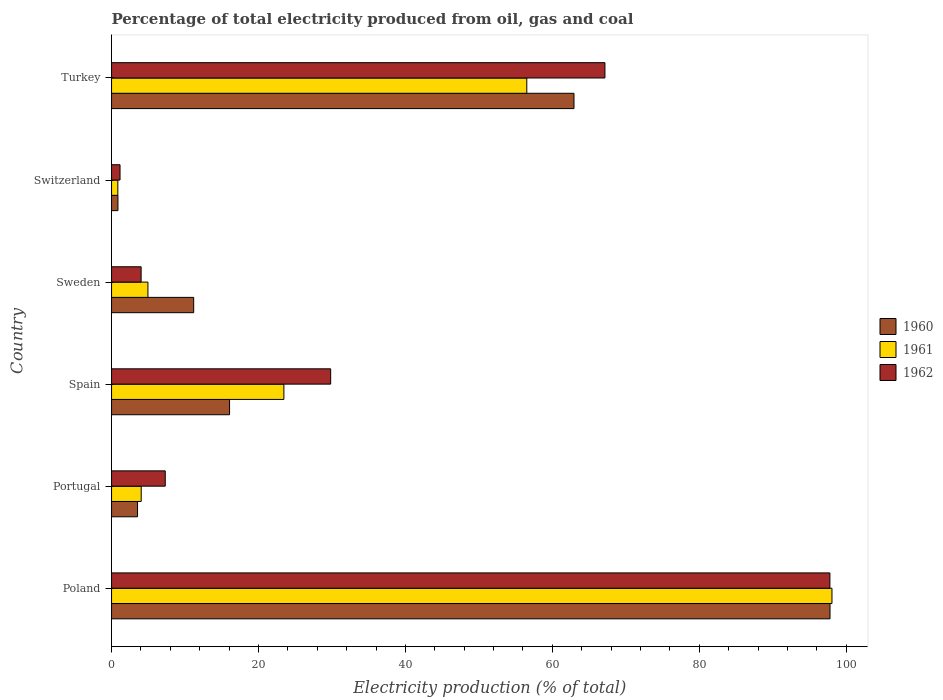How many groups of bars are there?
Provide a short and direct response. 6. Are the number of bars per tick equal to the number of legend labels?
Offer a very short reply. Yes. What is the electricity production in in 1960 in Portugal?
Your response must be concise. 3.54. Across all countries, what is the maximum electricity production in in 1960?
Give a very brief answer. 97.8. Across all countries, what is the minimum electricity production in in 1962?
Make the answer very short. 1.15. In which country was the electricity production in in 1960 maximum?
Ensure brevity in your answer.  Poland. In which country was the electricity production in in 1960 minimum?
Offer a very short reply. Switzerland. What is the total electricity production in in 1961 in the graph?
Provide a short and direct response. 187.9. What is the difference between the electricity production in in 1961 in Poland and that in Turkey?
Your answer should be very brief. 41.54. What is the difference between the electricity production in in 1961 in Switzerland and the electricity production in in 1960 in Sweden?
Offer a terse response. -10.33. What is the average electricity production in in 1961 per country?
Your answer should be compact. 31.32. What is the difference between the electricity production in in 1960 and electricity production in in 1962 in Spain?
Your answer should be very brief. -13.76. What is the ratio of the electricity production in in 1962 in Portugal to that in Turkey?
Offer a very short reply. 0.11. Is the electricity production in in 1960 in Poland less than that in Spain?
Give a very brief answer. No. Is the difference between the electricity production in in 1960 in Sweden and Turkey greater than the difference between the electricity production in in 1962 in Sweden and Turkey?
Give a very brief answer. Yes. What is the difference between the highest and the second highest electricity production in in 1960?
Provide a succinct answer. 34.85. What is the difference between the highest and the lowest electricity production in in 1960?
Make the answer very short. 96.93. What does the 2nd bar from the bottom in Turkey represents?
Your answer should be very brief. 1961. Is it the case that in every country, the sum of the electricity production in in 1960 and electricity production in in 1961 is greater than the electricity production in in 1962?
Keep it short and to the point. Yes. Are all the bars in the graph horizontal?
Your answer should be very brief. Yes. How many countries are there in the graph?
Your answer should be very brief. 6. What is the difference between two consecutive major ticks on the X-axis?
Provide a short and direct response. 20. Are the values on the major ticks of X-axis written in scientific E-notation?
Make the answer very short. No. Does the graph contain any zero values?
Provide a short and direct response. No. Does the graph contain grids?
Provide a short and direct response. No. Where does the legend appear in the graph?
Make the answer very short. Center right. How many legend labels are there?
Give a very brief answer. 3. How are the legend labels stacked?
Ensure brevity in your answer.  Vertical. What is the title of the graph?
Offer a very short reply. Percentage of total electricity produced from oil, gas and coal. What is the label or title of the X-axis?
Give a very brief answer. Electricity production (% of total). What is the Electricity production (% of total) of 1960 in Poland?
Provide a short and direct response. 97.8. What is the Electricity production (% of total) of 1961 in Poland?
Offer a very short reply. 98.07. What is the Electricity production (% of total) of 1962 in Poland?
Offer a very short reply. 97.79. What is the Electricity production (% of total) in 1960 in Portugal?
Provide a short and direct response. 3.54. What is the Electricity production (% of total) of 1961 in Portugal?
Provide a succinct answer. 4.04. What is the Electricity production (% of total) of 1962 in Portugal?
Make the answer very short. 7.31. What is the Electricity production (% of total) in 1960 in Spain?
Give a very brief answer. 16.06. What is the Electricity production (% of total) in 1961 in Spain?
Provide a short and direct response. 23.46. What is the Electricity production (% of total) of 1962 in Spain?
Your response must be concise. 29.83. What is the Electricity production (% of total) of 1960 in Sweden?
Provide a short and direct response. 11.18. What is the Electricity production (% of total) of 1961 in Sweden?
Your answer should be compact. 4.95. What is the Electricity production (% of total) of 1962 in Sweden?
Give a very brief answer. 4.02. What is the Electricity production (% of total) in 1960 in Switzerland?
Your answer should be compact. 0.87. What is the Electricity production (% of total) in 1961 in Switzerland?
Offer a terse response. 0.85. What is the Electricity production (% of total) in 1962 in Switzerland?
Ensure brevity in your answer.  1.15. What is the Electricity production (% of total) of 1960 in Turkey?
Keep it short and to the point. 62.95. What is the Electricity production (% of total) of 1961 in Turkey?
Provide a succinct answer. 56.53. What is the Electricity production (% of total) in 1962 in Turkey?
Provide a short and direct response. 67.16. Across all countries, what is the maximum Electricity production (% of total) in 1960?
Provide a short and direct response. 97.8. Across all countries, what is the maximum Electricity production (% of total) of 1961?
Provide a succinct answer. 98.07. Across all countries, what is the maximum Electricity production (% of total) of 1962?
Offer a very short reply. 97.79. Across all countries, what is the minimum Electricity production (% of total) in 1960?
Keep it short and to the point. 0.87. Across all countries, what is the minimum Electricity production (% of total) in 1961?
Keep it short and to the point. 0.85. Across all countries, what is the minimum Electricity production (% of total) of 1962?
Your answer should be compact. 1.15. What is the total Electricity production (% of total) in 1960 in the graph?
Keep it short and to the point. 192.4. What is the total Electricity production (% of total) of 1961 in the graph?
Give a very brief answer. 187.9. What is the total Electricity production (% of total) in 1962 in the graph?
Provide a short and direct response. 207.26. What is the difference between the Electricity production (% of total) in 1960 in Poland and that in Portugal?
Ensure brevity in your answer.  94.26. What is the difference between the Electricity production (% of total) in 1961 in Poland and that in Portugal?
Offer a very short reply. 94.03. What is the difference between the Electricity production (% of total) in 1962 in Poland and that in Portugal?
Provide a short and direct response. 90.48. What is the difference between the Electricity production (% of total) in 1960 in Poland and that in Spain?
Give a very brief answer. 81.74. What is the difference between the Electricity production (% of total) of 1961 in Poland and that in Spain?
Provide a short and direct response. 74.61. What is the difference between the Electricity production (% of total) in 1962 in Poland and that in Spain?
Make the answer very short. 67.96. What is the difference between the Electricity production (% of total) in 1960 in Poland and that in Sweden?
Give a very brief answer. 86.62. What is the difference between the Electricity production (% of total) in 1961 in Poland and that in Sweden?
Ensure brevity in your answer.  93.12. What is the difference between the Electricity production (% of total) in 1962 in Poland and that in Sweden?
Make the answer very short. 93.76. What is the difference between the Electricity production (% of total) of 1960 in Poland and that in Switzerland?
Provide a succinct answer. 96.93. What is the difference between the Electricity production (% of total) in 1961 in Poland and that in Switzerland?
Provide a short and direct response. 97.21. What is the difference between the Electricity production (% of total) in 1962 in Poland and that in Switzerland?
Keep it short and to the point. 96.63. What is the difference between the Electricity production (% of total) of 1960 in Poland and that in Turkey?
Make the answer very short. 34.85. What is the difference between the Electricity production (% of total) in 1961 in Poland and that in Turkey?
Provide a succinct answer. 41.54. What is the difference between the Electricity production (% of total) of 1962 in Poland and that in Turkey?
Provide a short and direct response. 30.62. What is the difference between the Electricity production (% of total) of 1960 in Portugal and that in Spain?
Offer a very short reply. -12.53. What is the difference between the Electricity production (% of total) of 1961 in Portugal and that in Spain?
Your answer should be compact. -19.42. What is the difference between the Electricity production (% of total) in 1962 in Portugal and that in Spain?
Ensure brevity in your answer.  -22.52. What is the difference between the Electricity production (% of total) of 1960 in Portugal and that in Sweden?
Keep it short and to the point. -7.64. What is the difference between the Electricity production (% of total) of 1961 in Portugal and that in Sweden?
Your response must be concise. -0.92. What is the difference between the Electricity production (% of total) of 1962 in Portugal and that in Sweden?
Offer a terse response. 3.28. What is the difference between the Electricity production (% of total) in 1960 in Portugal and that in Switzerland?
Offer a very short reply. 2.67. What is the difference between the Electricity production (% of total) in 1961 in Portugal and that in Switzerland?
Provide a short and direct response. 3.18. What is the difference between the Electricity production (% of total) of 1962 in Portugal and that in Switzerland?
Make the answer very short. 6.16. What is the difference between the Electricity production (% of total) of 1960 in Portugal and that in Turkey?
Your answer should be very brief. -59.41. What is the difference between the Electricity production (% of total) in 1961 in Portugal and that in Turkey?
Give a very brief answer. -52.49. What is the difference between the Electricity production (% of total) in 1962 in Portugal and that in Turkey?
Your answer should be compact. -59.85. What is the difference between the Electricity production (% of total) in 1960 in Spain and that in Sweden?
Ensure brevity in your answer.  4.88. What is the difference between the Electricity production (% of total) of 1961 in Spain and that in Sweden?
Your answer should be very brief. 18.51. What is the difference between the Electricity production (% of total) of 1962 in Spain and that in Sweden?
Provide a short and direct response. 25.8. What is the difference between the Electricity production (% of total) in 1960 in Spain and that in Switzerland?
Make the answer very short. 15.19. What is the difference between the Electricity production (% of total) in 1961 in Spain and that in Switzerland?
Your response must be concise. 22.61. What is the difference between the Electricity production (% of total) in 1962 in Spain and that in Switzerland?
Give a very brief answer. 28.67. What is the difference between the Electricity production (% of total) of 1960 in Spain and that in Turkey?
Provide a succinct answer. -46.89. What is the difference between the Electricity production (% of total) in 1961 in Spain and that in Turkey?
Provide a short and direct response. -33.07. What is the difference between the Electricity production (% of total) in 1962 in Spain and that in Turkey?
Your response must be concise. -37.34. What is the difference between the Electricity production (% of total) of 1960 in Sweden and that in Switzerland?
Your response must be concise. 10.31. What is the difference between the Electricity production (% of total) of 1961 in Sweden and that in Switzerland?
Your answer should be compact. 4.1. What is the difference between the Electricity production (% of total) of 1962 in Sweden and that in Switzerland?
Your answer should be compact. 2.87. What is the difference between the Electricity production (% of total) of 1960 in Sweden and that in Turkey?
Your answer should be very brief. -51.77. What is the difference between the Electricity production (% of total) in 1961 in Sweden and that in Turkey?
Offer a very short reply. -51.57. What is the difference between the Electricity production (% of total) in 1962 in Sweden and that in Turkey?
Offer a terse response. -63.14. What is the difference between the Electricity production (% of total) of 1960 in Switzerland and that in Turkey?
Provide a short and direct response. -62.08. What is the difference between the Electricity production (% of total) in 1961 in Switzerland and that in Turkey?
Your response must be concise. -55.67. What is the difference between the Electricity production (% of total) in 1962 in Switzerland and that in Turkey?
Offer a very short reply. -66.01. What is the difference between the Electricity production (% of total) of 1960 in Poland and the Electricity production (% of total) of 1961 in Portugal?
Make the answer very short. 93.76. What is the difference between the Electricity production (% of total) of 1960 in Poland and the Electricity production (% of total) of 1962 in Portugal?
Your answer should be compact. 90.49. What is the difference between the Electricity production (% of total) in 1961 in Poland and the Electricity production (% of total) in 1962 in Portugal?
Offer a terse response. 90.76. What is the difference between the Electricity production (% of total) in 1960 in Poland and the Electricity production (% of total) in 1961 in Spain?
Your answer should be compact. 74.34. What is the difference between the Electricity production (% of total) in 1960 in Poland and the Electricity production (% of total) in 1962 in Spain?
Provide a short and direct response. 67.97. What is the difference between the Electricity production (% of total) in 1961 in Poland and the Electricity production (% of total) in 1962 in Spain?
Keep it short and to the point. 68.24. What is the difference between the Electricity production (% of total) in 1960 in Poland and the Electricity production (% of total) in 1961 in Sweden?
Make the answer very short. 92.85. What is the difference between the Electricity production (% of total) of 1960 in Poland and the Electricity production (% of total) of 1962 in Sweden?
Ensure brevity in your answer.  93.78. What is the difference between the Electricity production (% of total) in 1961 in Poland and the Electricity production (% of total) in 1962 in Sweden?
Offer a very short reply. 94.04. What is the difference between the Electricity production (% of total) in 1960 in Poland and the Electricity production (% of total) in 1961 in Switzerland?
Your answer should be very brief. 96.95. What is the difference between the Electricity production (% of total) in 1960 in Poland and the Electricity production (% of total) in 1962 in Switzerland?
Provide a succinct answer. 96.65. What is the difference between the Electricity production (% of total) of 1961 in Poland and the Electricity production (% of total) of 1962 in Switzerland?
Offer a very short reply. 96.91. What is the difference between the Electricity production (% of total) in 1960 in Poland and the Electricity production (% of total) in 1961 in Turkey?
Your response must be concise. 41.27. What is the difference between the Electricity production (% of total) of 1960 in Poland and the Electricity production (% of total) of 1962 in Turkey?
Provide a succinct answer. 30.64. What is the difference between the Electricity production (% of total) of 1961 in Poland and the Electricity production (% of total) of 1962 in Turkey?
Offer a terse response. 30.9. What is the difference between the Electricity production (% of total) of 1960 in Portugal and the Electricity production (% of total) of 1961 in Spain?
Your response must be concise. -19.92. What is the difference between the Electricity production (% of total) of 1960 in Portugal and the Electricity production (% of total) of 1962 in Spain?
Your answer should be compact. -26.29. What is the difference between the Electricity production (% of total) in 1961 in Portugal and the Electricity production (% of total) in 1962 in Spain?
Provide a succinct answer. -25.79. What is the difference between the Electricity production (% of total) of 1960 in Portugal and the Electricity production (% of total) of 1961 in Sweden?
Your answer should be compact. -1.41. What is the difference between the Electricity production (% of total) of 1960 in Portugal and the Electricity production (% of total) of 1962 in Sweden?
Keep it short and to the point. -0.49. What is the difference between the Electricity production (% of total) of 1961 in Portugal and the Electricity production (% of total) of 1962 in Sweden?
Keep it short and to the point. 0.01. What is the difference between the Electricity production (% of total) of 1960 in Portugal and the Electricity production (% of total) of 1961 in Switzerland?
Your answer should be compact. 2.68. What is the difference between the Electricity production (% of total) of 1960 in Portugal and the Electricity production (% of total) of 1962 in Switzerland?
Offer a terse response. 2.38. What is the difference between the Electricity production (% of total) in 1961 in Portugal and the Electricity production (% of total) in 1962 in Switzerland?
Make the answer very short. 2.88. What is the difference between the Electricity production (% of total) in 1960 in Portugal and the Electricity production (% of total) in 1961 in Turkey?
Provide a short and direct response. -52.99. What is the difference between the Electricity production (% of total) of 1960 in Portugal and the Electricity production (% of total) of 1962 in Turkey?
Provide a succinct answer. -63.63. What is the difference between the Electricity production (% of total) of 1961 in Portugal and the Electricity production (% of total) of 1962 in Turkey?
Provide a succinct answer. -63.13. What is the difference between the Electricity production (% of total) in 1960 in Spain and the Electricity production (% of total) in 1961 in Sweden?
Make the answer very short. 11.11. What is the difference between the Electricity production (% of total) of 1960 in Spain and the Electricity production (% of total) of 1962 in Sweden?
Ensure brevity in your answer.  12.04. What is the difference between the Electricity production (% of total) in 1961 in Spain and the Electricity production (% of total) in 1962 in Sweden?
Your response must be concise. 19.44. What is the difference between the Electricity production (% of total) in 1960 in Spain and the Electricity production (% of total) in 1961 in Switzerland?
Make the answer very short. 15.21. What is the difference between the Electricity production (% of total) of 1960 in Spain and the Electricity production (% of total) of 1962 in Switzerland?
Offer a very short reply. 14.91. What is the difference between the Electricity production (% of total) in 1961 in Spain and the Electricity production (% of total) in 1962 in Switzerland?
Offer a terse response. 22.31. What is the difference between the Electricity production (% of total) in 1960 in Spain and the Electricity production (% of total) in 1961 in Turkey?
Provide a short and direct response. -40.46. What is the difference between the Electricity production (% of total) in 1960 in Spain and the Electricity production (% of total) in 1962 in Turkey?
Keep it short and to the point. -51.1. What is the difference between the Electricity production (% of total) in 1961 in Spain and the Electricity production (% of total) in 1962 in Turkey?
Offer a terse response. -43.7. What is the difference between the Electricity production (% of total) of 1960 in Sweden and the Electricity production (% of total) of 1961 in Switzerland?
Provide a succinct answer. 10.33. What is the difference between the Electricity production (% of total) in 1960 in Sweden and the Electricity production (% of total) in 1962 in Switzerland?
Offer a terse response. 10.03. What is the difference between the Electricity production (% of total) in 1961 in Sweden and the Electricity production (% of total) in 1962 in Switzerland?
Ensure brevity in your answer.  3.8. What is the difference between the Electricity production (% of total) of 1960 in Sweden and the Electricity production (% of total) of 1961 in Turkey?
Provide a short and direct response. -45.35. What is the difference between the Electricity production (% of total) in 1960 in Sweden and the Electricity production (% of total) in 1962 in Turkey?
Give a very brief answer. -55.98. What is the difference between the Electricity production (% of total) of 1961 in Sweden and the Electricity production (% of total) of 1962 in Turkey?
Your answer should be very brief. -62.21. What is the difference between the Electricity production (% of total) of 1960 in Switzerland and the Electricity production (% of total) of 1961 in Turkey?
Keep it short and to the point. -55.66. What is the difference between the Electricity production (% of total) of 1960 in Switzerland and the Electricity production (% of total) of 1962 in Turkey?
Your answer should be very brief. -66.29. What is the difference between the Electricity production (% of total) in 1961 in Switzerland and the Electricity production (% of total) in 1962 in Turkey?
Make the answer very short. -66.31. What is the average Electricity production (% of total) of 1960 per country?
Provide a short and direct response. 32.07. What is the average Electricity production (% of total) of 1961 per country?
Ensure brevity in your answer.  31.32. What is the average Electricity production (% of total) of 1962 per country?
Make the answer very short. 34.54. What is the difference between the Electricity production (% of total) of 1960 and Electricity production (% of total) of 1961 in Poland?
Give a very brief answer. -0.27. What is the difference between the Electricity production (% of total) in 1960 and Electricity production (% of total) in 1962 in Poland?
Ensure brevity in your answer.  0.01. What is the difference between the Electricity production (% of total) of 1961 and Electricity production (% of total) of 1962 in Poland?
Provide a short and direct response. 0.28. What is the difference between the Electricity production (% of total) of 1960 and Electricity production (% of total) of 1961 in Portugal?
Keep it short and to the point. -0.5. What is the difference between the Electricity production (% of total) in 1960 and Electricity production (% of total) in 1962 in Portugal?
Your answer should be compact. -3.77. What is the difference between the Electricity production (% of total) in 1961 and Electricity production (% of total) in 1962 in Portugal?
Provide a succinct answer. -3.27. What is the difference between the Electricity production (% of total) in 1960 and Electricity production (% of total) in 1961 in Spain?
Provide a short and direct response. -7.4. What is the difference between the Electricity production (% of total) of 1960 and Electricity production (% of total) of 1962 in Spain?
Make the answer very short. -13.76. What is the difference between the Electricity production (% of total) of 1961 and Electricity production (% of total) of 1962 in Spain?
Offer a terse response. -6.37. What is the difference between the Electricity production (% of total) in 1960 and Electricity production (% of total) in 1961 in Sweden?
Offer a terse response. 6.23. What is the difference between the Electricity production (% of total) of 1960 and Electricity production (% of total) of 1962 in Sweden?
Make the answer very short. 7.16. What is the difference between the Electricity production (% of total) of 1961 and Electricity production (% of total) of 1962 in Sweden?
Your answer should be compact. 0.93. What is the difference between the Electricity production (% of total) in 1960 and Electricity production (% of total) in 1961 in Switzerland?
Your answer should be very brief. 0.02. What is the difference between the Electricity production (% of total) of 1960 and Electricity production (% of total) of 1962 in Switzerland?
Your answer should be very brief. -0.28. What is the difference between the Electricity production (% of total) in 1961 and Electricity production (% of total) in 1962 in Switzerland?
Your answer should be very brief. -0.3. What is the difference between the Electricity production (% of total) in 1960 and Electricity production (% of total) in 1961 in Turkey?
Provide a short and direct response. 6.42. What is the difference between the Electricity production (% of total) of 1960 and Electricity production (% of total) of 1962 in Turkey?
Give a very brief answer. -4.21. What is the difference between the Electricity production (% of total) in 1961 and Electricity production (% of total) in 1962 in Turkey?
Your answer should be compact. -10.64. What is the ratio of the Electricity production (% of total) of 1960 in Poland to that in Portugal?
Offer a very short reply. 27.65. What is the ratio of the Electricity production (% of total) in 1961 in Poland to that in Portugal?
Offer a terse response. 24.3. What is the ratio of the Electricity production (% of total) in 1962 in Poland to that in Portugal?
Your response must be concise. 13.38. What is the ratio of the Electricity production (% of total) in 1960 in Poland to that in Spain?
Offer a terse response. 6.09. What is the ratio of the Electricity production (% of total) in 1961 in Poland to that in Spain?
Offer a very short reply. 4.18. What is the ratio of the Electricity production (% of total) in 1962 in Poland to that in Spain?
Your answer should be very brief. 3.28. What is the ratio of the Electricity production (% of total) of 1960 in Poland to that in Sweden?
Your answer should be compact. 8.75. What is the ratio of the Electricity production (% of total) in 1961 in Poland to that in Sweden?
Provide a succinct answer. 19.8. What is the ratio of the Electricity production (% of total) in 1962 in Poland to that in Sweden?
Give a very brief answer. 24.3. What is the ratio of the Electricity production (% of total) of 1960 in Poland to that in Switzerland?
Your answer should be very brief. 112.47. What is the ratio of the Electricity production (% of total) in 1961 in Poland to that in Switzerland?
Offer a terse response. 114.89. What is the ratio of the Electricity production (% of total) of 1962 in Poland to that in Switzerland?
Give a very brief answer. 84.78. What is the ratio of the Electricity production (% of total) of 1960 in Poland to that in Turkey?
Make the answer very short. 1.55. What is the ratio of the Electricity production (% of total) in 1961 in Poland to that in Turkey?
Your answer should be very brief. 1.73. What is the ratio of the Electricity production (% of total) of 1962 in Poland to that in Turkey?
Make the answer very short. 1.46. What is the ratio of the Electricity production (% of total) of 1960 in Portugal to that in Spain?
Offer a terse response. 0.22. What is the ratio of the Electricity production (% of total) in 1961 in Portugal to that in Spain?
Ensure brevity in your answer.  0.17. What is the ratio of the Electricity production (% of total) in 1962 in Portugal to that in Spain?
Offer a very short reply. 0.24. What is the ratio of the Electricity production (% of total) of 1960 in Portugal to that in Sweden?
Give a very brief answer. 0.32. What is the ratio of the Electricity production (% of total) in 1961 in Portugal to that in Sweden?
Give a very brief answer. 0.82. What is the ratio of the Electricity production (% of total) in 1962 in Portugal to that in Sweden?
Your answer should be compact. 1.82. What is the ratio of the Electricity production (% of total) of 1960 in Portugal to that in Switzerland?
Your response must be concise. 4.07. What is the ratio of the Electricity production (% of total) of 1961 in Portugal to that in Switzerland?
Provide a short and direct response. 4.73. What is the ratio of the Electricity production (% of total) in 1962 in Portugal to that in Switzerland?
Your response must be concise. 6.34. What is the ratio of the Electricity production (% of total) of 1960 in Portugal to that in Turkey?
Offer a terse response. 0.06. What is the ratio of the Electricity production (% of total) of 1961 in Portugal to that in Turkey?
Keep it short and to the point. 0.07. What is the ratio of the Electricity production (% of total) in 1962 in Portugal to that in Turkey?
Offer a very short reply. 0.11. What is the ratio of the Electricity production (% of total) of 1960 in Spain to that in Sweden?
Your answer should be compact. 1.44. What is the ratio of the Electricity production (% of total) in 1961 in Spain to that in Sweden?
Provide a succinct answer. 4.74. What is the ratio of the Electricity production (% of total) in 1962 in Spain to that in Sweden?
Your answer should be compact. 7.41. What is the ratio of the Electricity production (% of total) in 1960 in Spain to that in Switzerland?
Provide a succinct answer. 18.47. What is the ratio of the Electricity production (% of total) in 1961 in Spain to that in Switzerland?
Keep it short and to the point. 27.48. What is the ratio of the Electricity production (% of total) of 1962 in Spain to that in Switzerland?
Ensure brevity in your answer.  25.86. What is the ratio of the Electricity production (% of total) of 1960 in Spain to that in Turkey?
Provide a short and direct response. 0.26. What is the ratio of the Electricity production (% of total) in 1961 in Spain to that in Turkey?
Your response must be concise. 0.41. What is the ratio of the Electricity production (% of total) in 1962 in Spain to that in Turkey?
Your response must be concise. 0.44. What is the ratio of the Electricity production (% of total) of 1960 in Sweden to that in Switzerland?
Give a very brief answer. 12.86. What is the ratio of the Electricity production (% of total) in 1961 in Sweden to that in Switzerland?
Keep it short and to the point. 5.8. What is the ratio of the Electricity production (% of total) of 1962 in Sweden to that in Switzerland?
Your answer should be very brief. 3.49. What is the ratio of the Electricity production (% of total) in 1960 in Sweden to that in Turkey?
Your answer should be very brief. 0.18. What is the ratio of the Electricity production (% of total) of 1961 in Sweden to that in Turkey?
Your response must be concise. 0.09. What is the ratio of the Electricity production (% of total) of 1962 in Sweden to that in Turkey?
Offer a terse response. 0.06. What is the ratio of the Electricity production (% of total) in 1960 in Switzerland to that in Turkey?
Ensure brevity in your answer.  0.01. What is the ratio of the Electricity production (% of total) of 1961 in Switzerland to that in Turkey?
Your response must be concise. 0.02. What is the ratio of the Electricity production (% of total) in 1962 in Switzerland to that in Turkey?
Provide a short and direct response. 0.02. What is the difference between the highest and the second highest Electricity production (% of total) in 1960?
Keep it short and to the point. 34.85. What is the difference between the highest and the second highest Electricity production (% of total) in 1961?
Offer a terse response. 41.54. What is the difference between the highest and the second highest Electricity production (% of total) in 1962?
Offer a very short reply. 30.62. What is the difference between the highest and the lowest Electricity production (% of total) of 1960?
Ensure brevity in your answer.  96.93. What is the difference between the highest and the lowest Electricity production (% of total) of 1961?
Give a very brief answer. 97.21. What is the difference between the highest and the lowest Electricity production (% of total) in 1962?
Offer a very short reply. 96.63. 